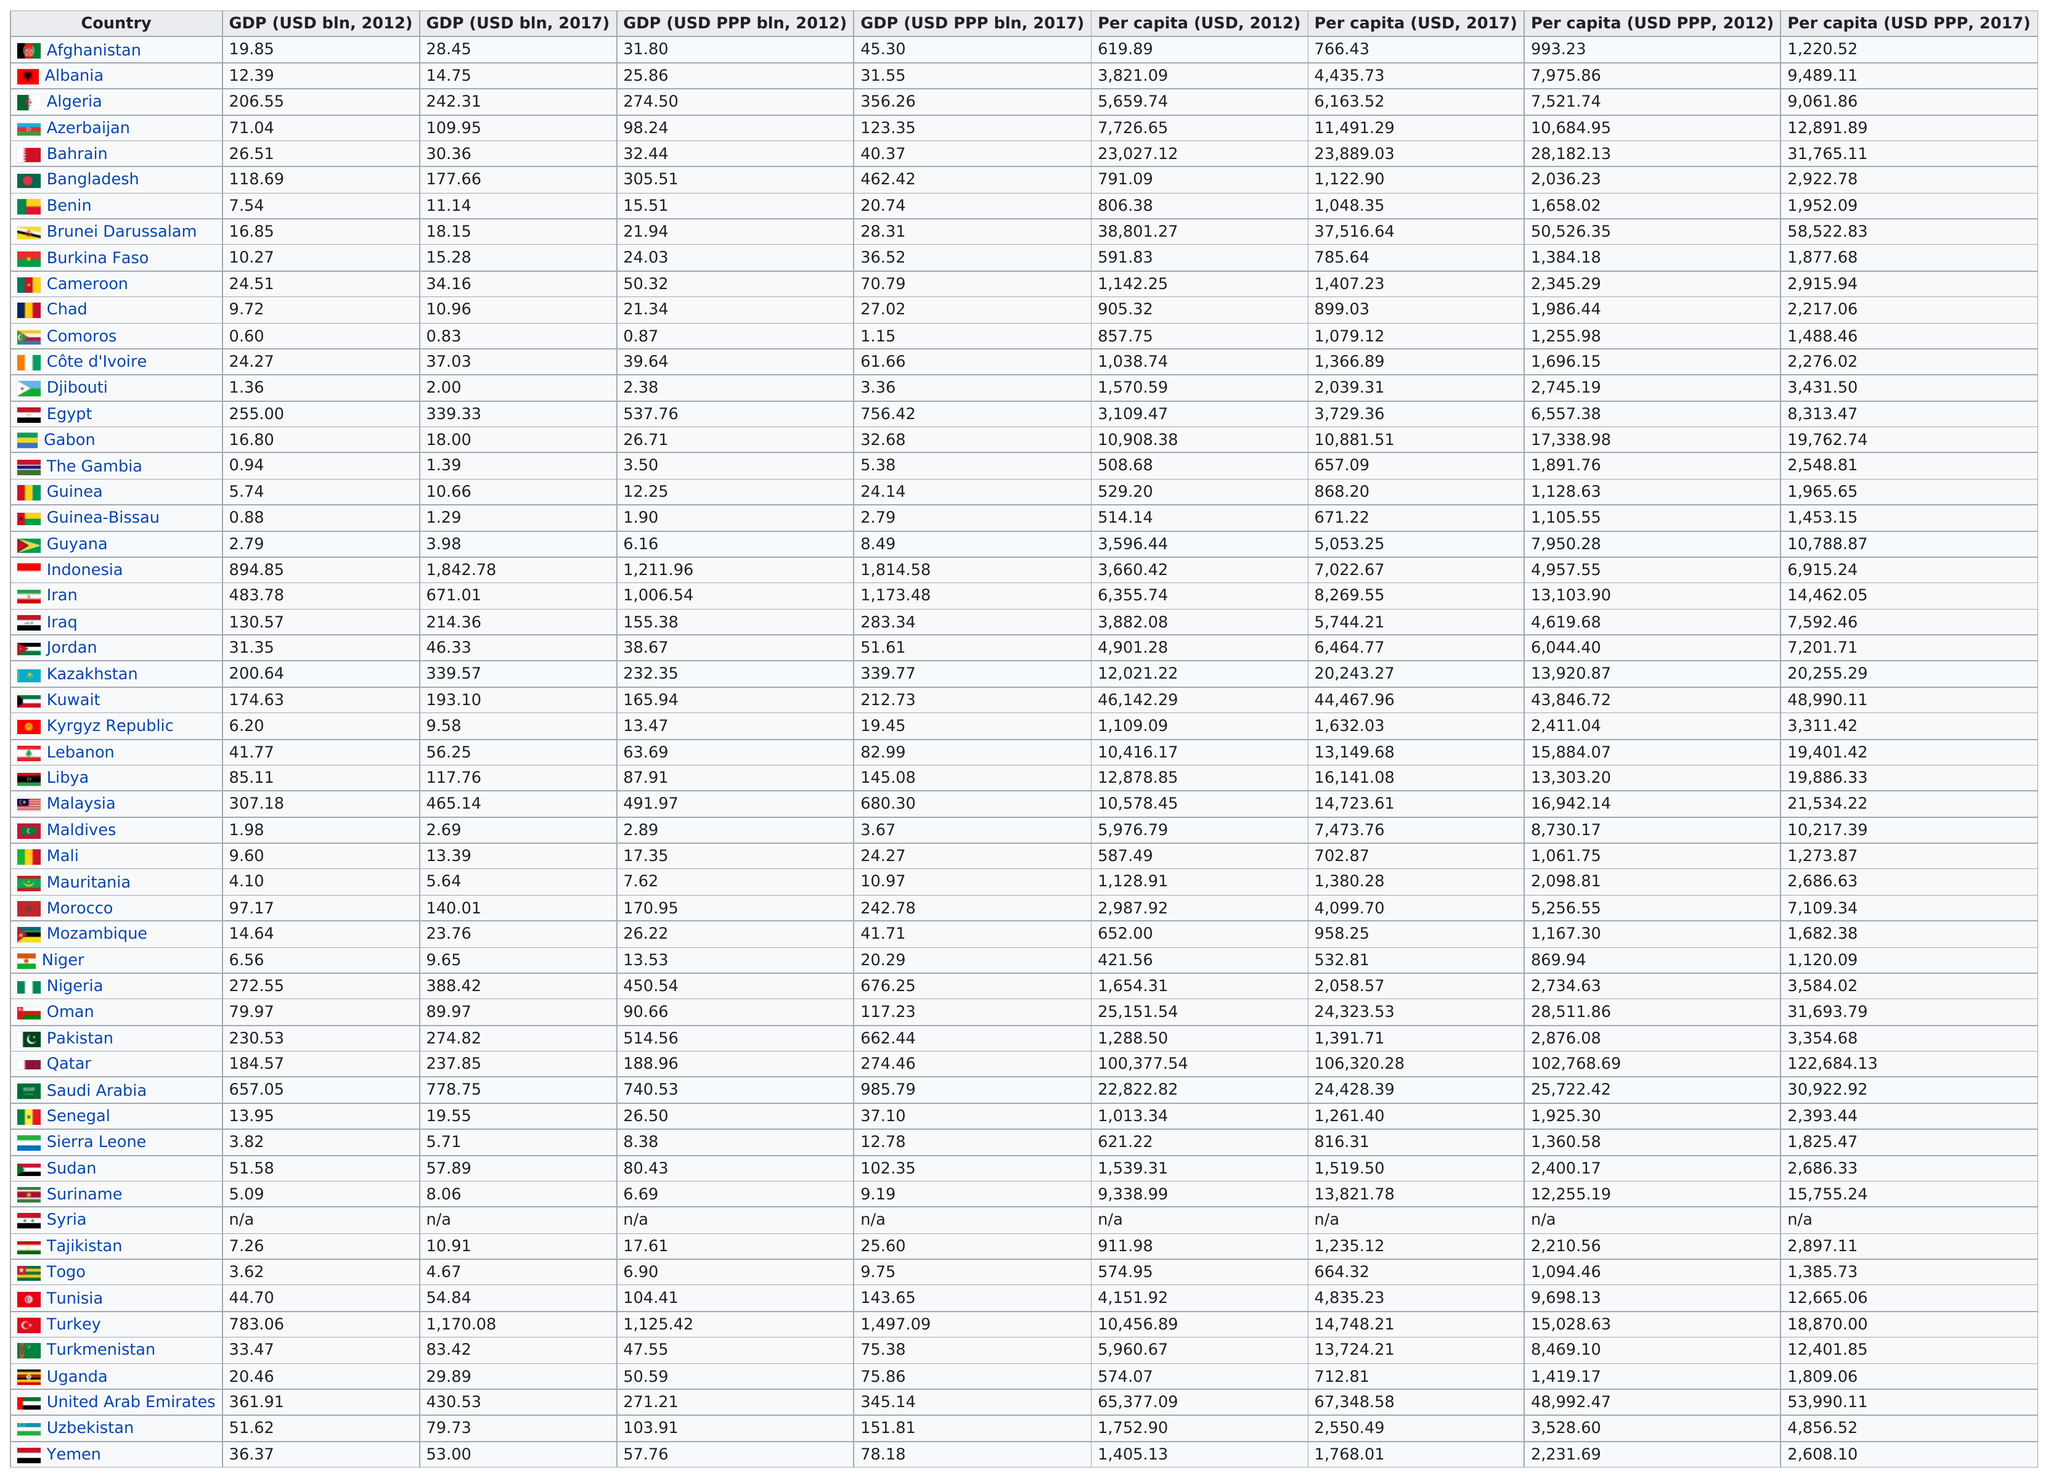Highlight a few significant elements in this photo. In 2012, there were 39 countries with a GDP (USD) of eight or greater. In 2012, Comoros had the lowest Gross Domestic Product (GDP) at Purchasing Power Parity (PPP) among all countries. In 2017, Qatar had the highest per capita (USD) among all countries. According to the 2017 GDP data, Indonesia had the highest GDP among all countries that year. The sum of the GDP (in USD PPP bin, 2012) between Niger and Sierra is 21.91. 